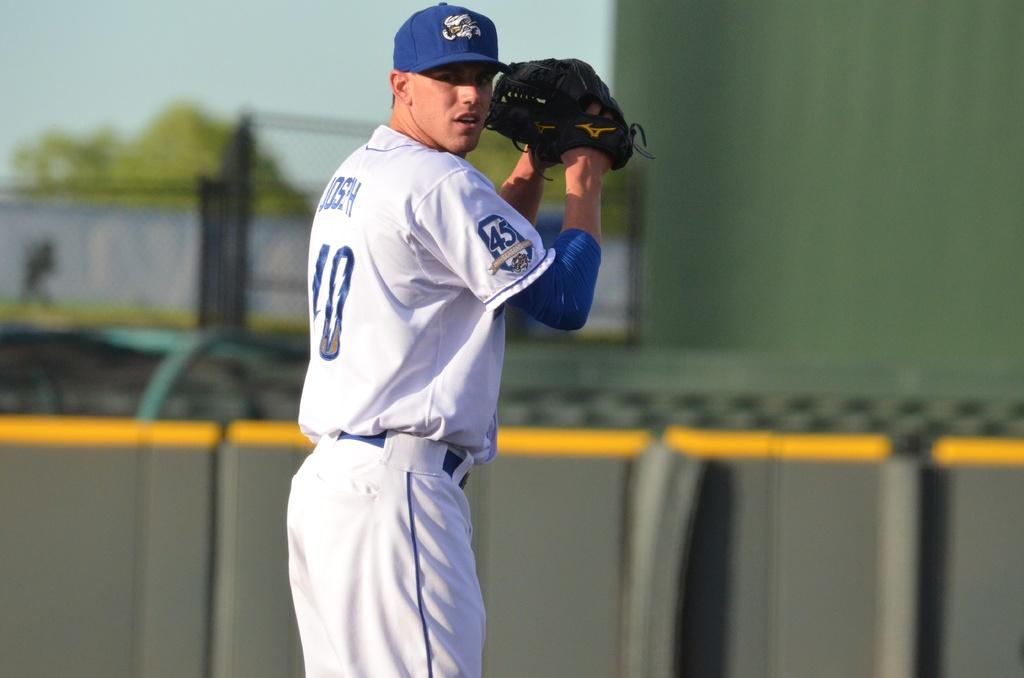<image>
Present a compact description of the photo's key features. Baseball playerwearing the number 45 on his sleeve about to pitch. 